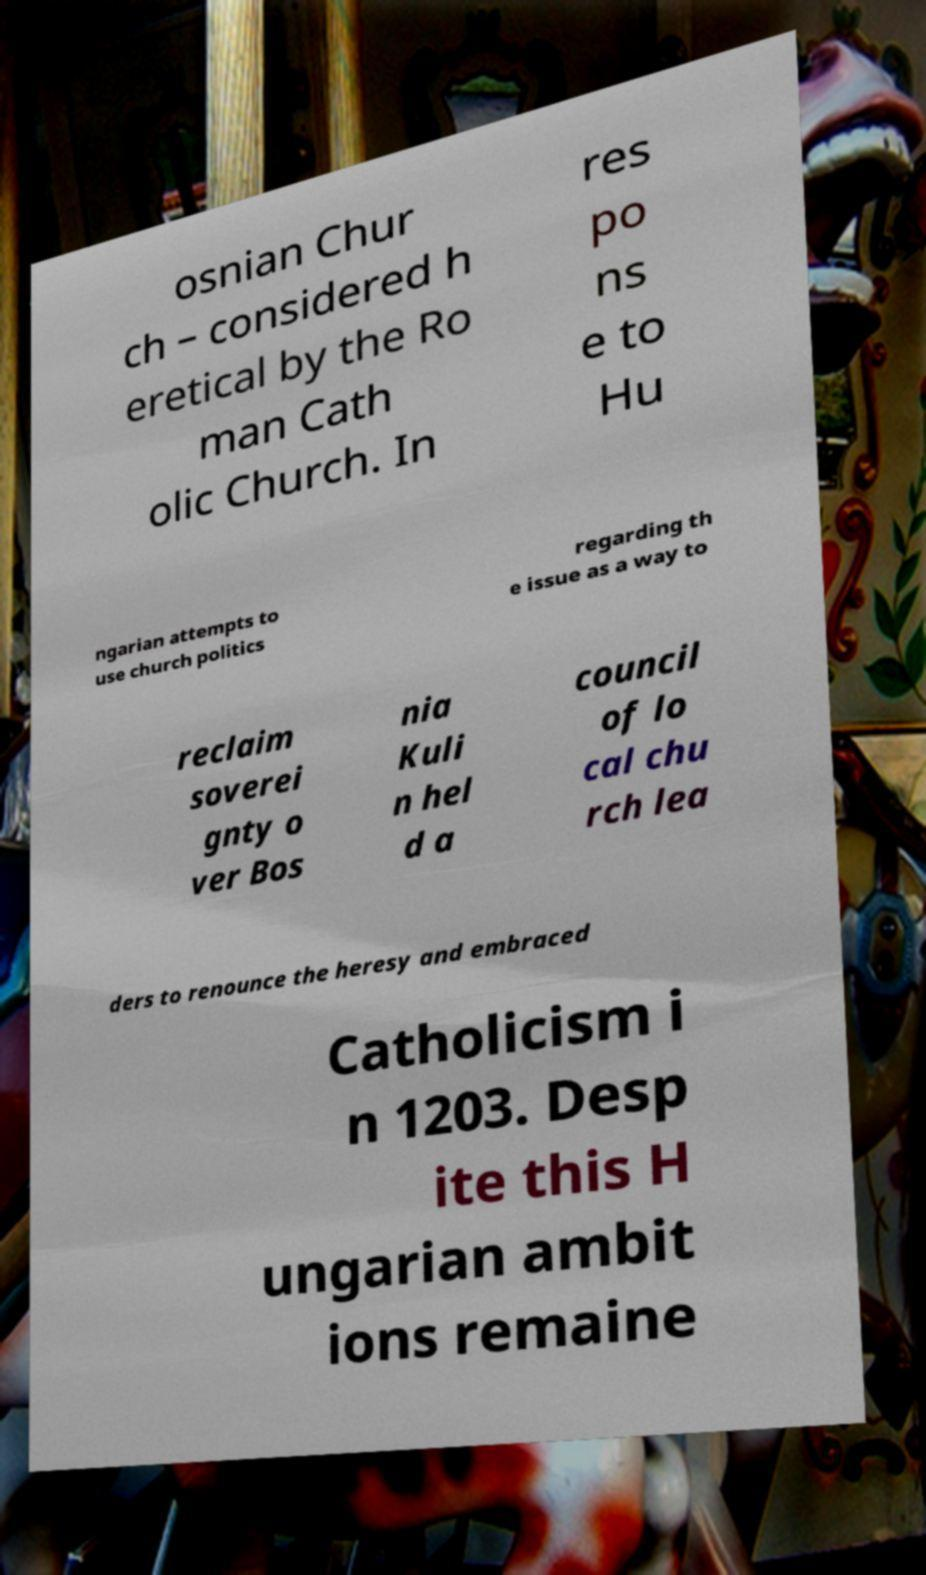Can you accurately transcribe the text from the provided image for me? osnian Chur ch – considered h eretical by the Ro man Cath olic Church. In res po ns e to Hu ngarian attempts to use church politics regarding th e issue as a way to reclaim soverei gnty o ver Bos nia Kuli n hel d a council of lo cal chu rch lea ders to renounce the heresy and embraced Catholicism i n 1203. Desp ite this H ungarian ambit ions remaine 